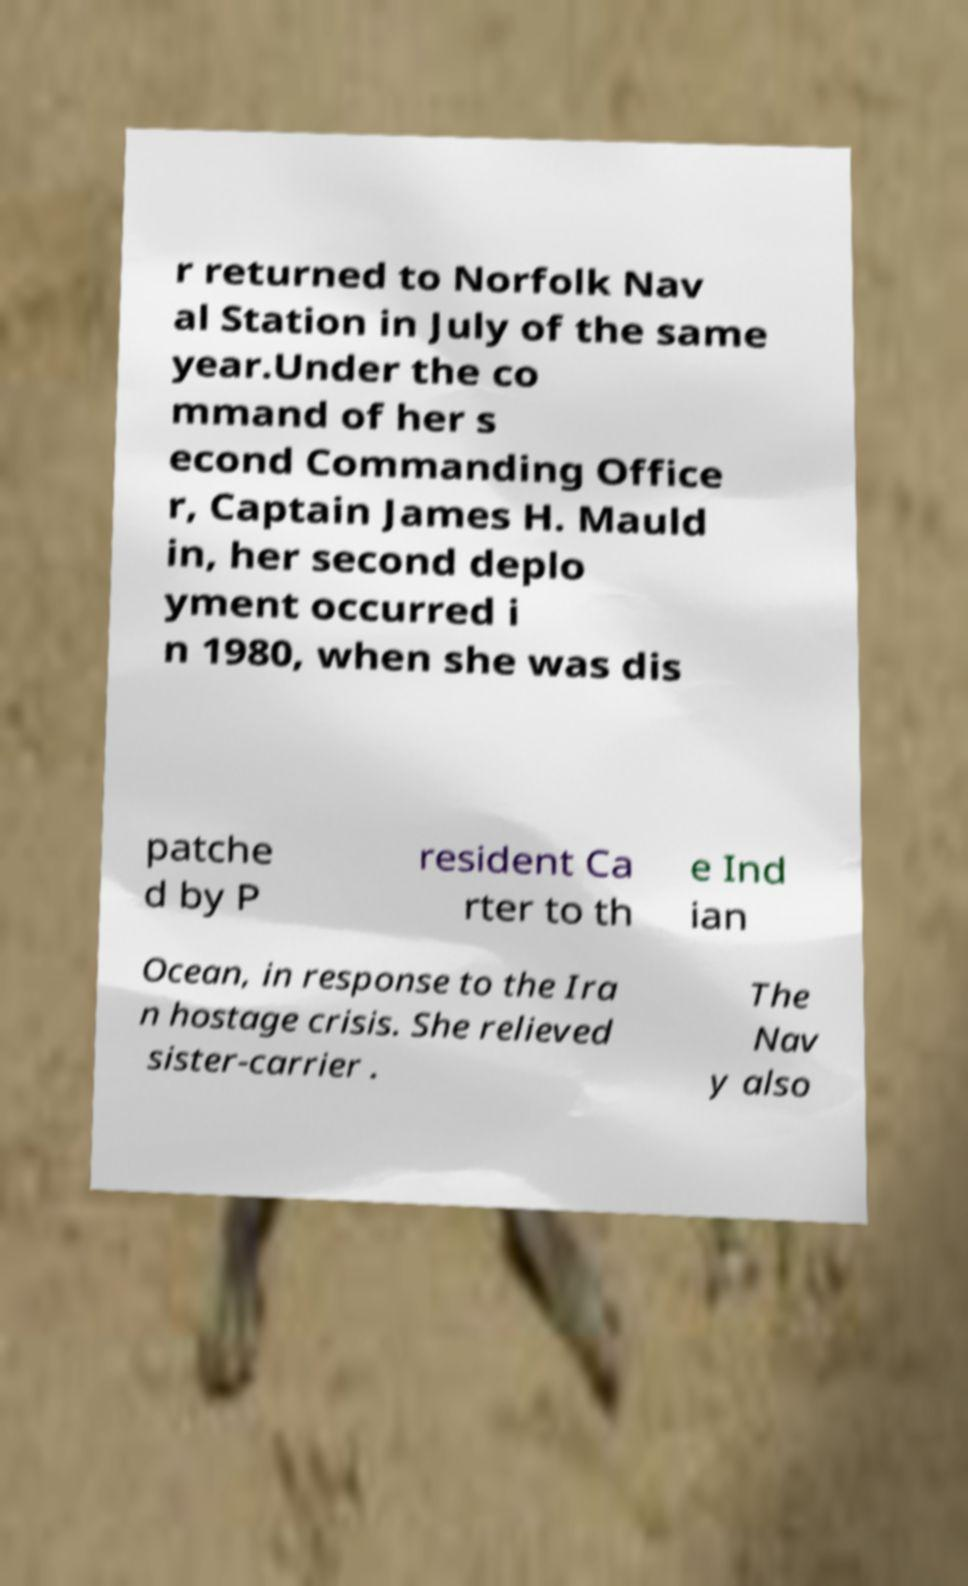Can you accurately transcribe the text from the provided image for me? r returned to Norfolk Nav al Station in July of the same year.Under the co mmand of her s econd Commanding Office r, Captain James H. Mauld in, her second deplo yment occurred i n 1980, when she was dis patche d by P resident Ca rter to th e Ind ian Ocean, in response to the Ira n hostage crisis. She relieved sister-carrier . The Nav y also 